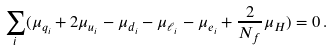<formula> <loc_0><loc_0><loc_500><loc_500>\sum _ { i } ( \mu _ { q _ { i } } + 2 \mu _ { u _ { i } } - \mu _ { d _ { i } } - \mu _ { \ell _ { i } } - \mu _ { e _ { i } } + \frac { 2 } { N _ { f } } \mu _ { H } ) = 0 \, .</formula> 